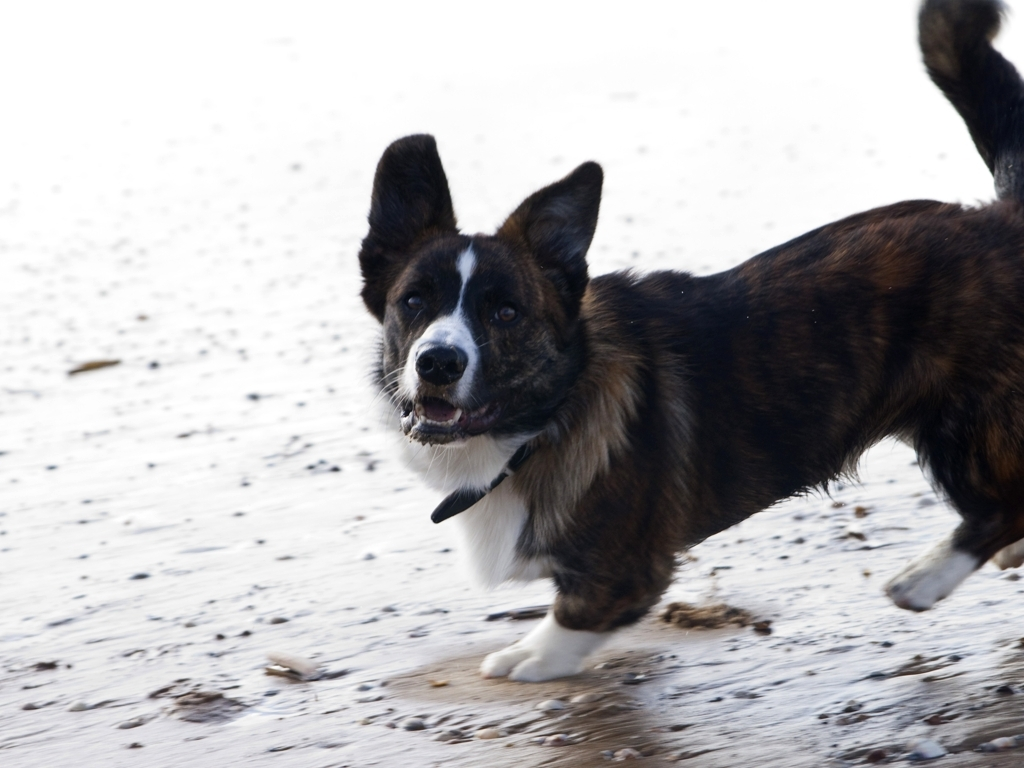How does the expression of the dog contribute to the overall mood of this picture? The dog's expression, with its mouth open and a bright gaze, adds a sense of vivacity and excitement to the image. It seems to be enjoying the moment, which can evoke a feeling of joy or playfulness in the viewer. 